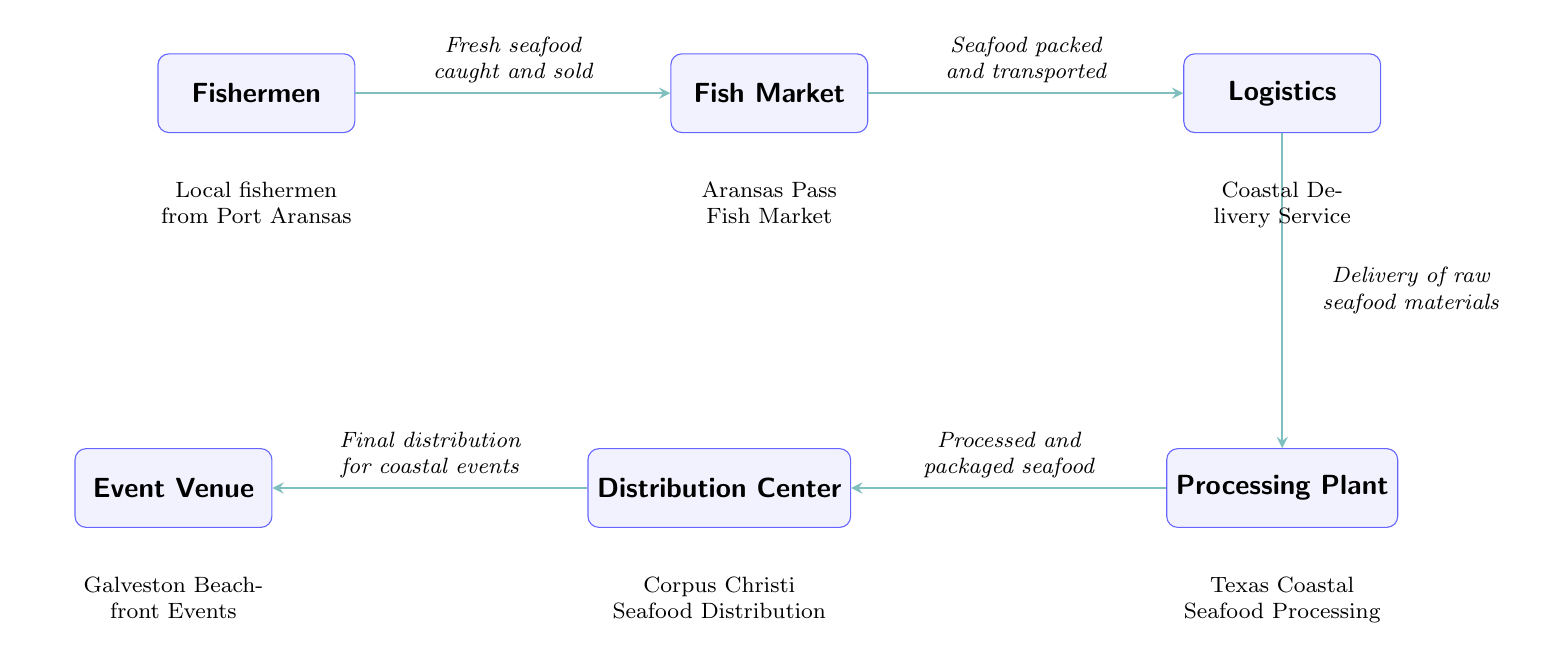What is the first node in the seafood distribution network? The first node in the diagram is labeled 'Fishermen', which indicates the starting point of the seafood distribution network.
Answer: Fishermen How many nodes are in the diagram? The diagram has a total of six nodes: Fishermen, Fish Market, Logistics, Processing Plant, Distribution Center, and Event Venue.
Answer: Six What is the second node in the seafood distribution process? The second node in the sequence is 'Fish Market', which follows 'Fishermen' in the diagram.
Answer: Fish Market What type of service is shown as taking seafood from the market to logistics? The service described in the arrow from 'Fish Market' to 'Logistics' is to transport packed seafood, indicating a logistics service is involved in this step.
Answer: Seafood packed and transported Which node comes before the 'Distribution Center'? The node immediately before the 'Distribution Center' is the 'Processing Plant', showing the flow of processed seafood moving to distribution.
Answer: Processing Plant How many arrows connect the nodes in the diagram? There are five arrows connecting the nodes in the diagram, each representing the flow of seafood from one point to the next in the distribution chain.
Answer: Five What does the label below the 'Logistics' node indicate? The label below 'Logistics' states 'Coastal Delivery Service', describing the type of service engaged in transportation logistics within the seafood distribution network.
Answer: Coastal Delivery Service Which entity manages the final distribution for coastal events? The final distribution for coastal events is managed by the 'Event Venue', which is the last node in the seafood distribution network.
Answer: Event Venue What type of seafood is handled at the 'Processing Plant'? The 'Processing Plant' handles 'Processed and packaged seafood', indicating that it prepares the seafood for eventual distribution.
Answer: Processed and packaged seafood 